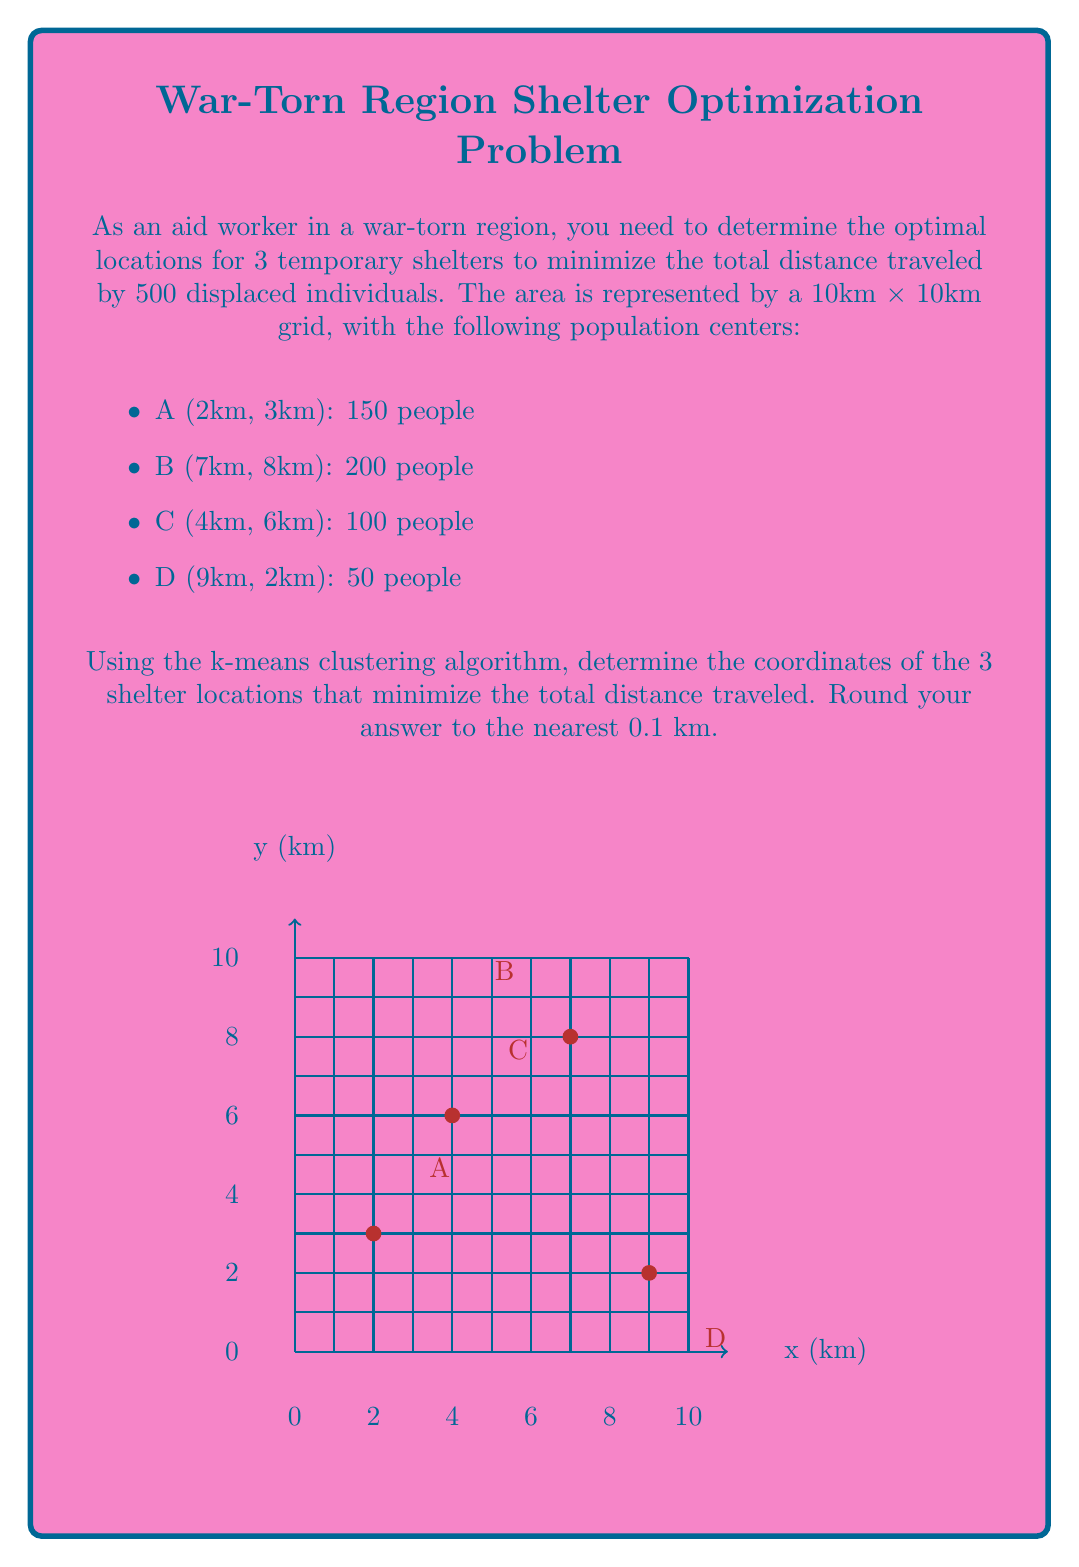Can you solve this math problem? To solve this problem using the k-means clustering algorithm, we'll follow these steps:

1) Initialize 3 random centroids (shelter locations).
2) Assign each population center to the nearest centroid.
3) Recalculate centroids based on the assigned population centers.
4) Repeat steps 2-3 until convergence.

Let's start with initial centroids:
$$C_1 = (3, 3), C_2 = (6, 6), C_3 = (8, 4)$$

Iteration 1:
1) Assign population centers to nearest centroids:
   A → C1, B → C2, C → C2, D → C3
2) Recalculate centroids:
   $$C_1 = (2, 3)$$
   $$C_2 = \left(\frac{7 \cdot 200 + 4 \cdot 100}{300}, \frac{8 \cdot 200 + 6 \cdot 100}{300}\right) = (6, 7.33)$$
   $$C_3 = (9, 2)$$

Iteration 2:
1) Reassign: A → C1, B → C2, C → C2, D → C3
2) Recalculate:
   $$C_1 = (2, 3)$$
   $$C_2 = (6, 7.33)$$
   $$C_3 = (9, 2)$$

The algorithm has converged as the centroids didn't change.

To get the final coordinates, we round to the nearest 0.1 km:
$$C_1 = (2.0, 3.0)$$
$$C_2 = (6.0, 7.3)$$
$$C_3 = (9.0, 2.0)$$
Answer: (2.0, 3.0), (6.0, 7.3), (9.0, 2.0) 